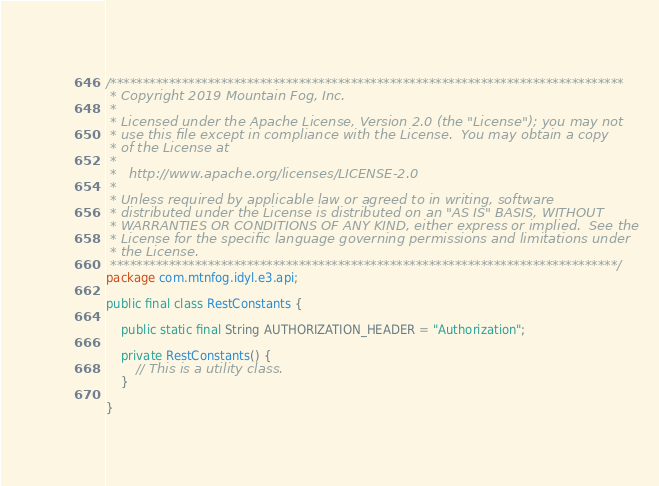<code> <loc_0><loc_0><loc_500><loc_500><_Java_>/*******************************************************************************
 * Copyright 2019 Mountain Fog, Inc.
 * 
 * Licensed under the Apache License, Version 2.0 (the "License"); you may not
 * use this file except in compliance with the License.  You may obtain a copy
 * of the License at
 * 
 *   http://www.apache.org/licenses/LICENSE-2.0
 * 
 * Unless required by applicable law or agreed to in writing, software
 * distributed under the License is distributed on an "AS IS" BASIS, WITHOUT
 * WARRANTIES OR CONDITIONS OF ANY KIND, either express or implied.  See the
 * License for the specific language governing permissions and limitations under
 * the License.
 ******************************************************************************/
package com.mtnfog.idyl.e3.api;

public final class RestConstants {
	
	public static final String AUTHORIZATION_HEADER = "Authorization";
	
	private RestConstants() {
		// This is a utility class.
	}
	
}
</code> 